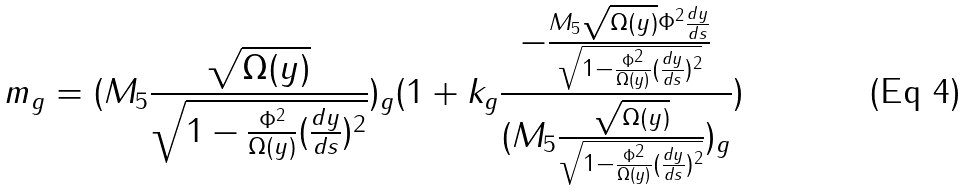Convert formula to latex. <formula><loc_0><loc_0><loc_500><loc_500>m _ { g } = ( M _ { 5 } \frac { \sqrt { \Omega ( y ) } } { \sqrt { 1 - \frac { \Phi ^ { 2 } } { \Omega ( y ) } ( \frac { d y } { d s } ) ^ { 2 } } } ) _ { g } ( 1 + k _ { g } \frac { - \frac { M _ { 5 } \sqrt { \Omega ( y ) } \Phi ^ { 2 } \frac { d y } { d s } } { \sqrt { 1 - \frac { \Phi ^ { 2 } } { \Omega ( y ) } ( \frac { d y } { d s } ) ^ { 2 } } } } { ( M _ { 5 } \frac { \sqrt { \Omega ( y ) } } { \sqrt { 1 - \frac { \Phi ^ { 2 } } { \Omega ( y ) } ( \frac { d y } { d s } ) ^ { 2 } } } ) _ { g } } )</formula> 